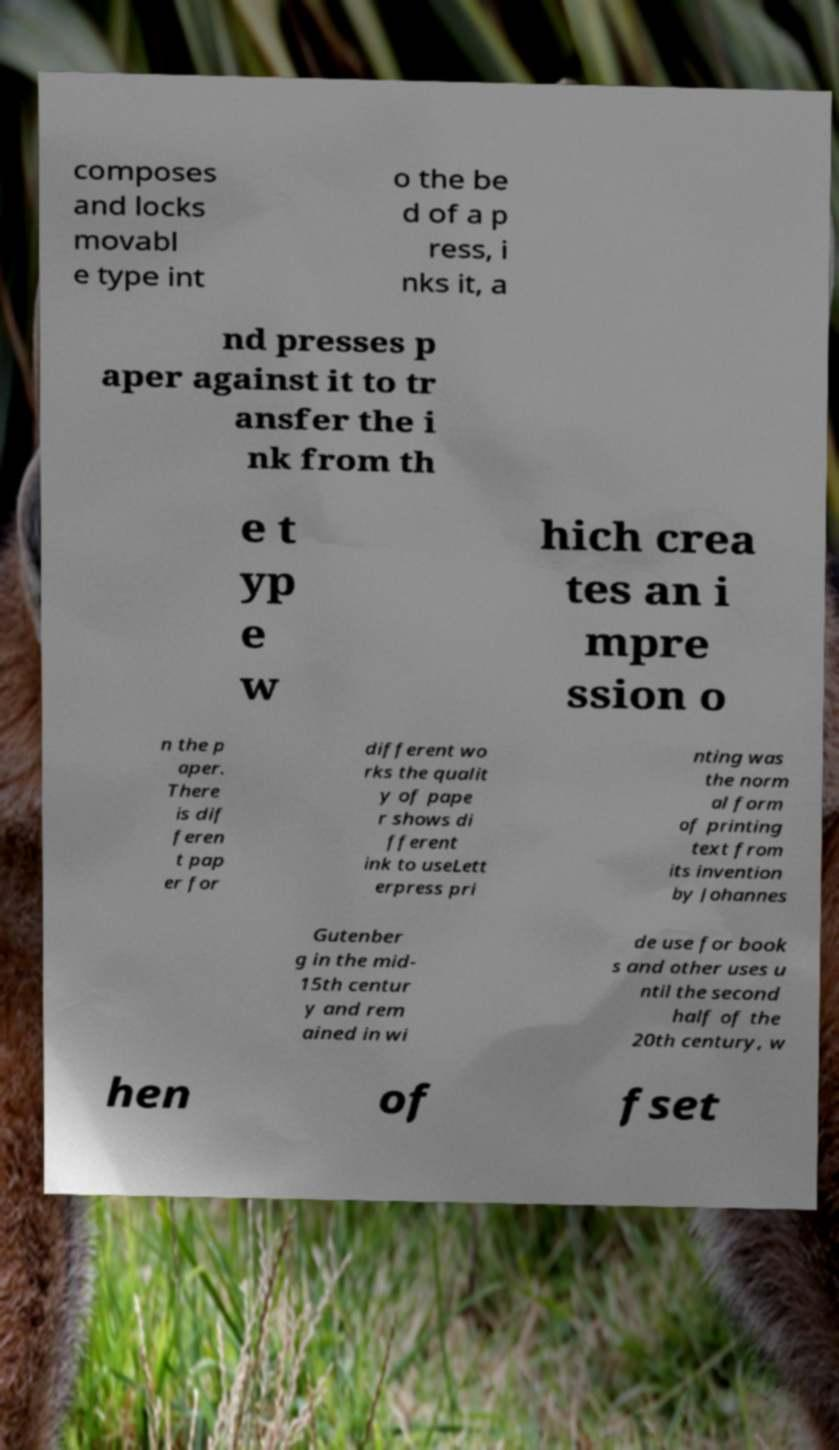Could you extract and type out the text from this image? composes and locks movabl e type int o the be d of a p ress, i nks it, a nd presses p aper against it to tr ansfer the i nk from th e t yp e w hich crea tes an i mpre ssion o n the p aper. There is dif feren t pap er for different wo rks the qualit y of pape r shows di fferent ink to useLett erpress pri nting was the norm al form of printing text from its invention by Johannes Gutenber g in the mid- 15th centur y and rem ained in wi de use for book s and other uses u ntil the second half of the 20th century, w hen of fset 